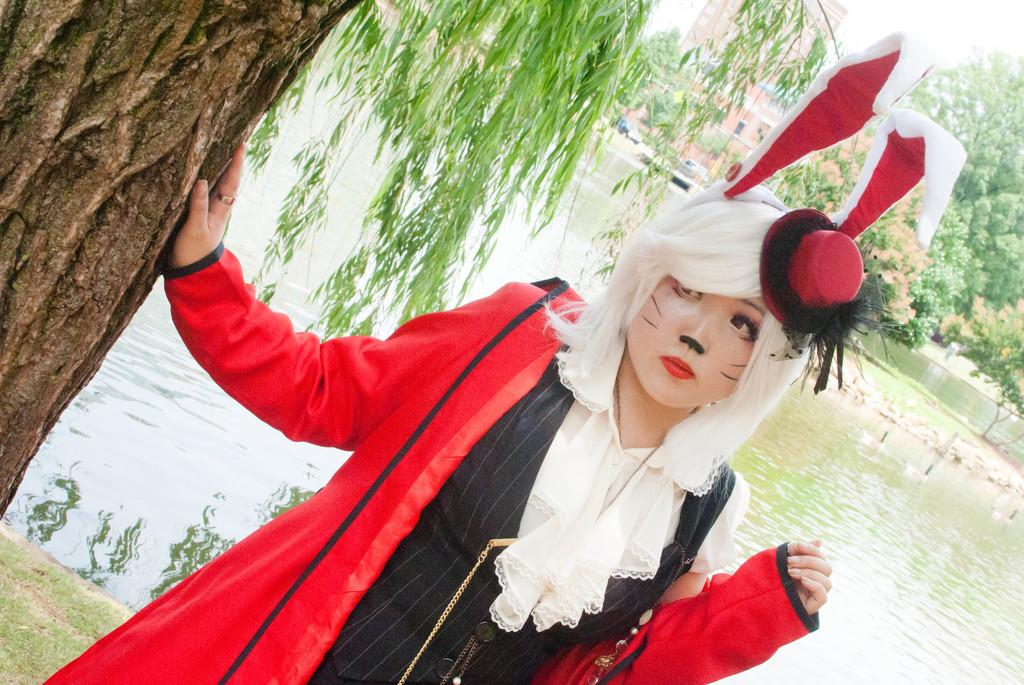What is the main subject of the image? There is a woman standing in the image. What is the woman wearing? The woman is wearing a jacket. What type of natural environment can be seen in the image? There are trees visible in the image. What type of man-made structures can be seen in the image? There is a building in the image. What else can be seen in the image besides the woman and the building? There are vehicles and water visible in the image. What book is the woman reading in the image? There is no book visible in the image, and the woman is not shown reading. 